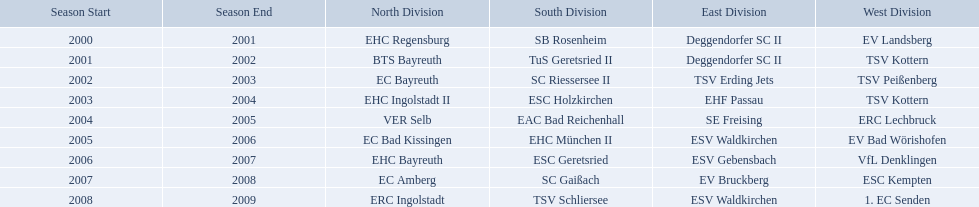Which teams won the north in their respective years? 2000-01, EHC Regensburg, BTS Bayreuth, EC Bayreuth, EHC Ingolstadt II, VER Selb, EC Bad Kissingen, EHC Bayreuth, EC Amberg, ERC Ingolstadt. Which one only won in 2000-01? EHC Regensburg. Parse the full table in json format. {'header': ['Season Start', 'Season End', 'North Division', 'South Division', 'East Division', 'West Division'], 'rows': [['2000', '2001', 'EHC Regensburg', 'SB Rosenheim', 'Deggendorfer SC II', 'EV Landsberg'], ['2001', '2002', 'BTS Bayreuth', 'TuS Geretsried II', 'Deggendorfer SC II', 'TSV Kottern'], ['2002', '2003', 'EC Bayreuth', 'SC Riessersee II', 'TSV Erding Jets', 'TSV Peißenberg'], ['2003', '2004', 'EHC Ingolstadt II', 'ESC Holzkirchen', 'EHF Passau', 'TSV Kottern'], ['2004', '2005', 'VER Selb', 'EAC Bad Reichenhall', 'SE Freising', 'ERC Lechbruck'], ['2005', '2006', 'EC Bad Kissingen', 'EHC München II', 'ESV Waldkirchen', 'EV Bad Wörishofen'], ['2006', '2007', 'EHC Bayreuth', 'ESC Geretsried', 'ESV Gebensbach', 'VfL Denklingen'], ['2007', '2008', 'EC Amberg', 'SC Gaißach', 'EV Bruckberg', 'ESC Kempten'], ['2008', '2009', 'ERC Ingolstadt', 'TSV Schliersee', 'ESV Waldkirchen', '1. EC Senden']]} Which teams have won in the bavarian ice hockey leagues between 2000 and 2009? EHC Regensburg, SB Rosenheim, Deggendorfer SC II, EV Landsberg, BTS Bayreuth, TuS Geretsried II, TSV Kottern, EC Bayreuth, SC Riessersee II, TSV Erding Jets, TSV Peißenberg, EHC Ingolstadt II, ESC Holzkirchen, EHF Passau, TSV Kottern, VER Selb, EAC Bad Reichenhall, SE Freising, ERC Lechbruck, EC Bad Kissingen, EHC München II, ESV Waldkirchen, EV Bad Wörishofen, EHC Bayreuth, ESC Geretsried, ESV Gebensbach, VfL Denklingen, EC Amberg, SC Gaißach, EV Bruckberg, ESC Kempten, ERC Ingolstadt, TSV Schliersee, ESV Waldkirchen, 1. EC Senden. Which of these winning teams have won the north? EHC Regensburg, BTS Bayreuth, EC Bayreuth, EHC Ingolstadt II, VER Selb, EC Bad Kissingen, EHC Bayreuth, EC Amberg, ERC Ingolstadt. Which of the teams that won the north won in the 2000/2001 season? EHC Regensburg. Would you mind parsing the complete table? {'header': ['Season Start', 'Season End', 'North Division', 'South Division', 'East Division', 'West Division'], 'rows': [['2000', '2001', 'EHC Regensburg', 'SB Rosenheim', 'Deggendorfer SC II', 'EV Landsberg'], ['2001', '2002', 'BTS Bayreuth', 'TuS Geretsried II', 'Deggendorfer SC II', 'TSV Kottern'], ['2002', '2003', 'EC Bayreuth', 'SC Riessersee II', 'TSV Erding Jets', 'TSV Peißenberg'], ['2003', '2004', 'EHC Ingolstadt II', 'ESC Holzkirchen', 'EHF Passau', 'TSV Kottern'], ['2004', '2005', 'VER Selb', 'EAC Bad Reichenhall', 'SE Freising', 'ERC Lechbruck'], ['2005', '2006', 'EC Bad Kissingen', 'EHC München II', 'ESV Waldkirchen', 'EV Bad Wörishofen'], ['2006', '2007', 'EHC Bayreuth', 'ESC Geretsried', 'ESV Gebensbach', 'VfL Denklingen'], ['2007', '2008', 'EC Amberg', 'SC Gaißach', 'EV Bruckberg', 'ESC Kempten'], ['2008', '2009', 'ERC Ingolstadt', 'TSV Schliersee', 'ESV Waldkirchen', '1. EC Senden']]} 